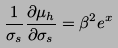Convert formula to latex. <formula><loc_0><loc_0><loc_500><loc_500>\frac { 1 } { \sigma _ { s } } \frac { \partial \mu _ { h } } { \partial \sigma _ { s } } = \beta ^ { 2 } e ^ { x }</formula> 